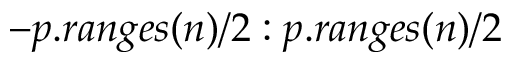<formula> <loc_0><loc_0><loc_500><loc_500>- p . r a n g e s ( n ) / 2 \colon p . r a n g e s ( n ) / 2</formula> 